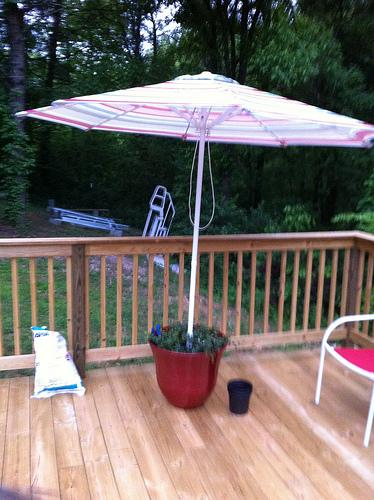Identify the primary focus of the image and describe its surroundings. A striped deck umbrella is the main focus, and it's surrounded by a wooden deck, a red planter with flowers, a red and white chair, a white bag of plant food, and trees in the background. Briefly describe the major objects in the picture and their colors. Major objects include a pink and white striped deck umbrella, red planter with blue flowers, red and white chair, white bag of plant food, and green trees. Highlight the elements that make the image unique and provide a concise description. The image features a large striped deck umbrella, creating a cozy atmosphere on the wooden deck with a red planter, blue flowers, a red and white chair, and a backdrop of trees. Mention the key components of the image and describe the setting. The key components are a striped deck umbrella, flowers in a red planter, a red and white chair, and a white bag of plant food, all situated on a wooden deck with trees in the back yard. Describe the key elements present in the image and their arrangement. Key elements include a large striped deck umbrella, red planter with blue flowers, red and white chair, white bag of plant food, and trees. They are arranged on a wooden deck with wooden railings, with trees in the back yard. Point out the main aspects of the image and describe their relationship to each other. The striped deck umbrella, red planter with blue flowers, and red and white chair, are placed on a wooden deck surrounded by wooden railings with trees in the background, making it a relaxing outdoor space. Describe the central elements and overall atmosphere of the image. The image features a large striped deck umbrella, red planter with blue flowers, red and white chair, and white bag of plant food, contributing to a calm and soothing outdoor environment. Narrate the overall ambience of the image while mentioning its essential components. The image showcases a serene outdoor setting on a sunny day featuring a striped deck umbrella, flowers in a red planter, a red and white chair, a bag of plant food, and lush trees in the background. Describe the picture while focusing on the items that make it feel inviting and pleasant. The image depicts an idyllic outdoor setting with a colorful striped deck umbrella, vibrant blue flowers in a red planter, a comfortable red and white chair, and lush green trees in the background. Mention the dominant feature in the image and detail its appearance. The dominant feature is the striped deck umbrella, which is large, open, and has pink and white stripes. 